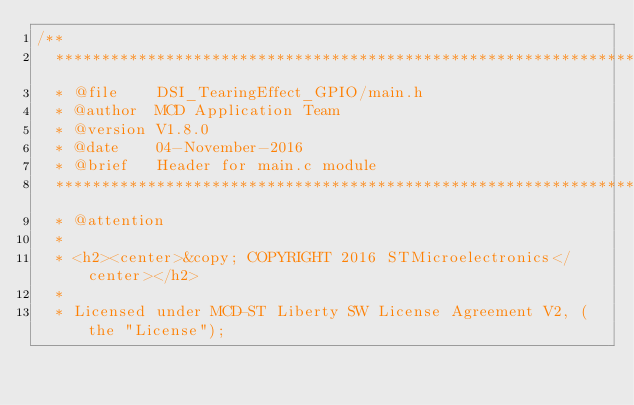<code> <loc_0><loc_0><loc_500><loc_500><_C_>/**
  ******************************************************************************
  * @file    DSI_TearingEffect_GPIO/main.h 
  * @author  MCD Application Team
  * @version V1.8.0
  * @date    04-November-2016
  * @brief   Header for main.c module
  ******************************************************************************
  * @attention
  *
  * <h2><center>&copy; COPYRIGHT 2016 STMicroelectronics</center></h2>
  *
  * Licensed under MCD-ST Liberty SW License Agreement V2, (the "License");</code> 